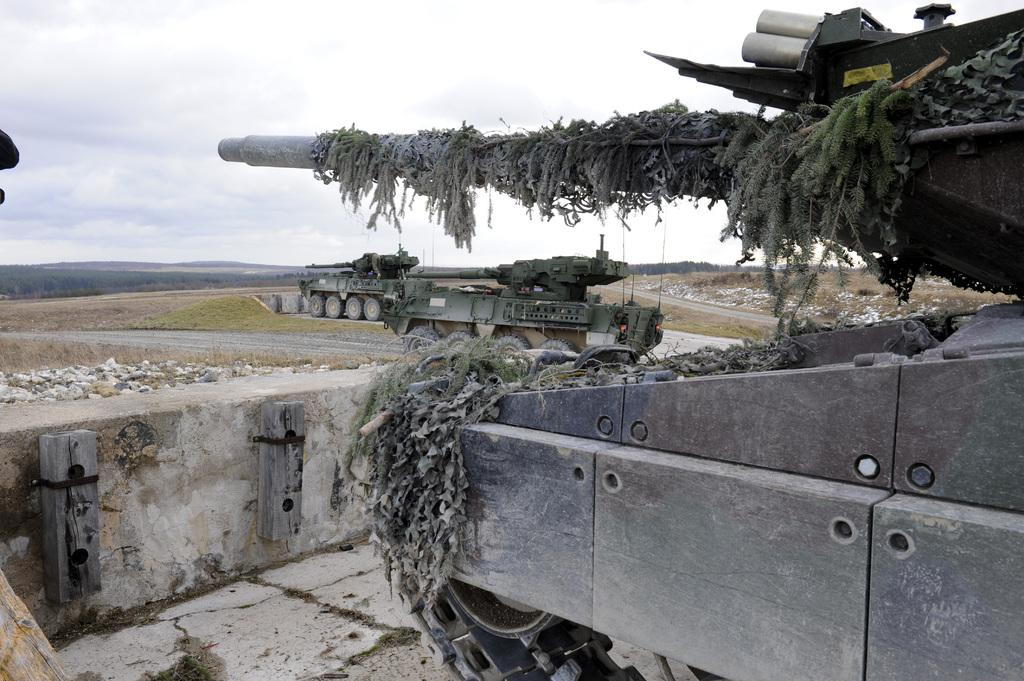What type of vehicles are in the image? There are tankers in the image. What is growing on one of the tankers? Grass is present on a tanker. What type of natural elements can be seen in the image? There are rocks and mountains in the image. What type of structure is in the image? There is a wall in the image. What is visible in the background of the image? The sky is visible in the image. What type of stove is visible in the image? There is no stove present in the image. What idea is being expressed by the tankers in the image? The image does not convey any specific ideas; it simply shows tankers, grass, rocks, a wall, the sky, and mountains. 